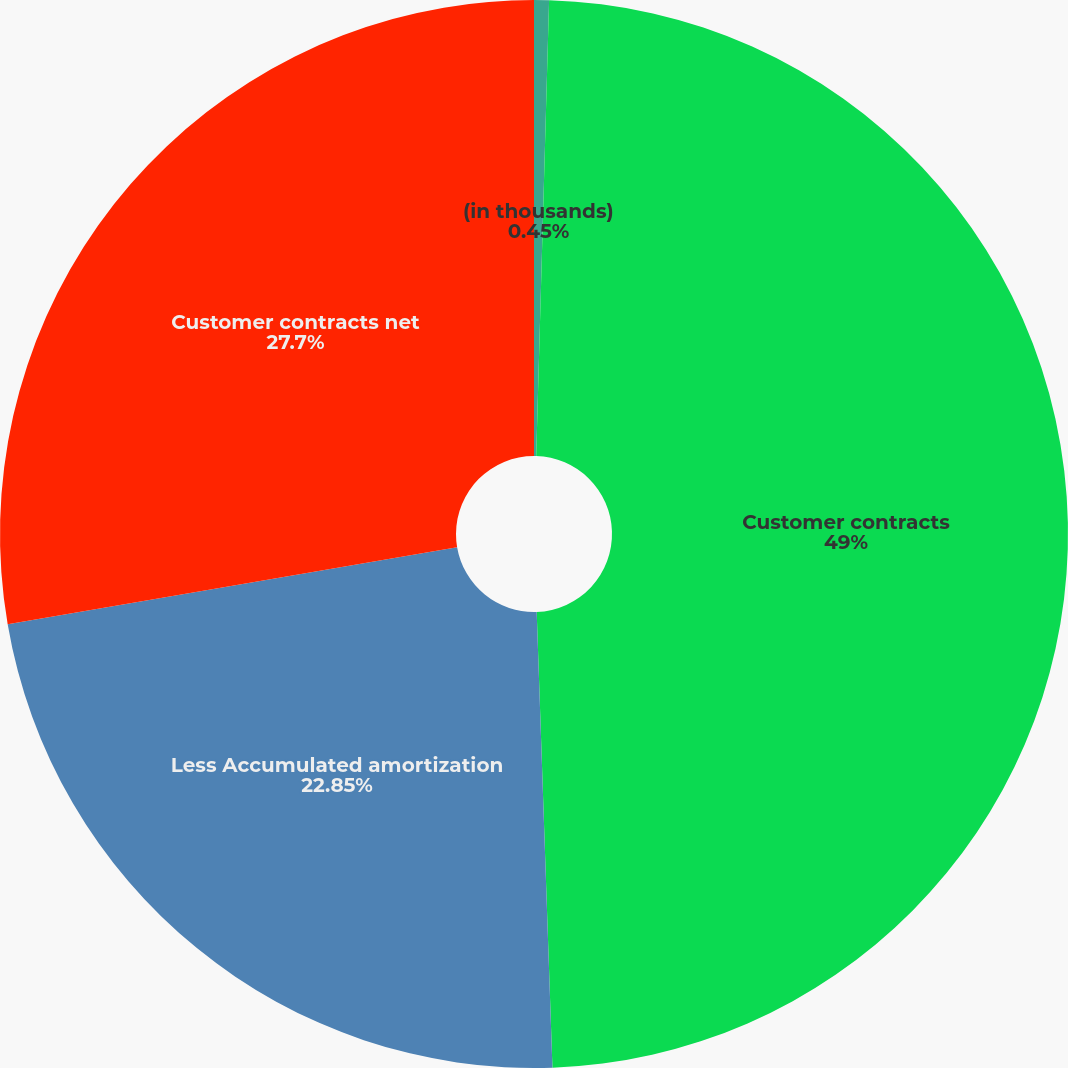Convert chart. <chart><loc_0><loc_0><loc_500><loc_500><pie_chart><fcel>(in thousands)<fcel>Customer contracts<fcel>Less Accumulated amortization<fcel>Customer contracts net<nl><fcel>0.45%<fcel>49.0%<fcel>22.85%<fcel>27.7%<nl></chart> 